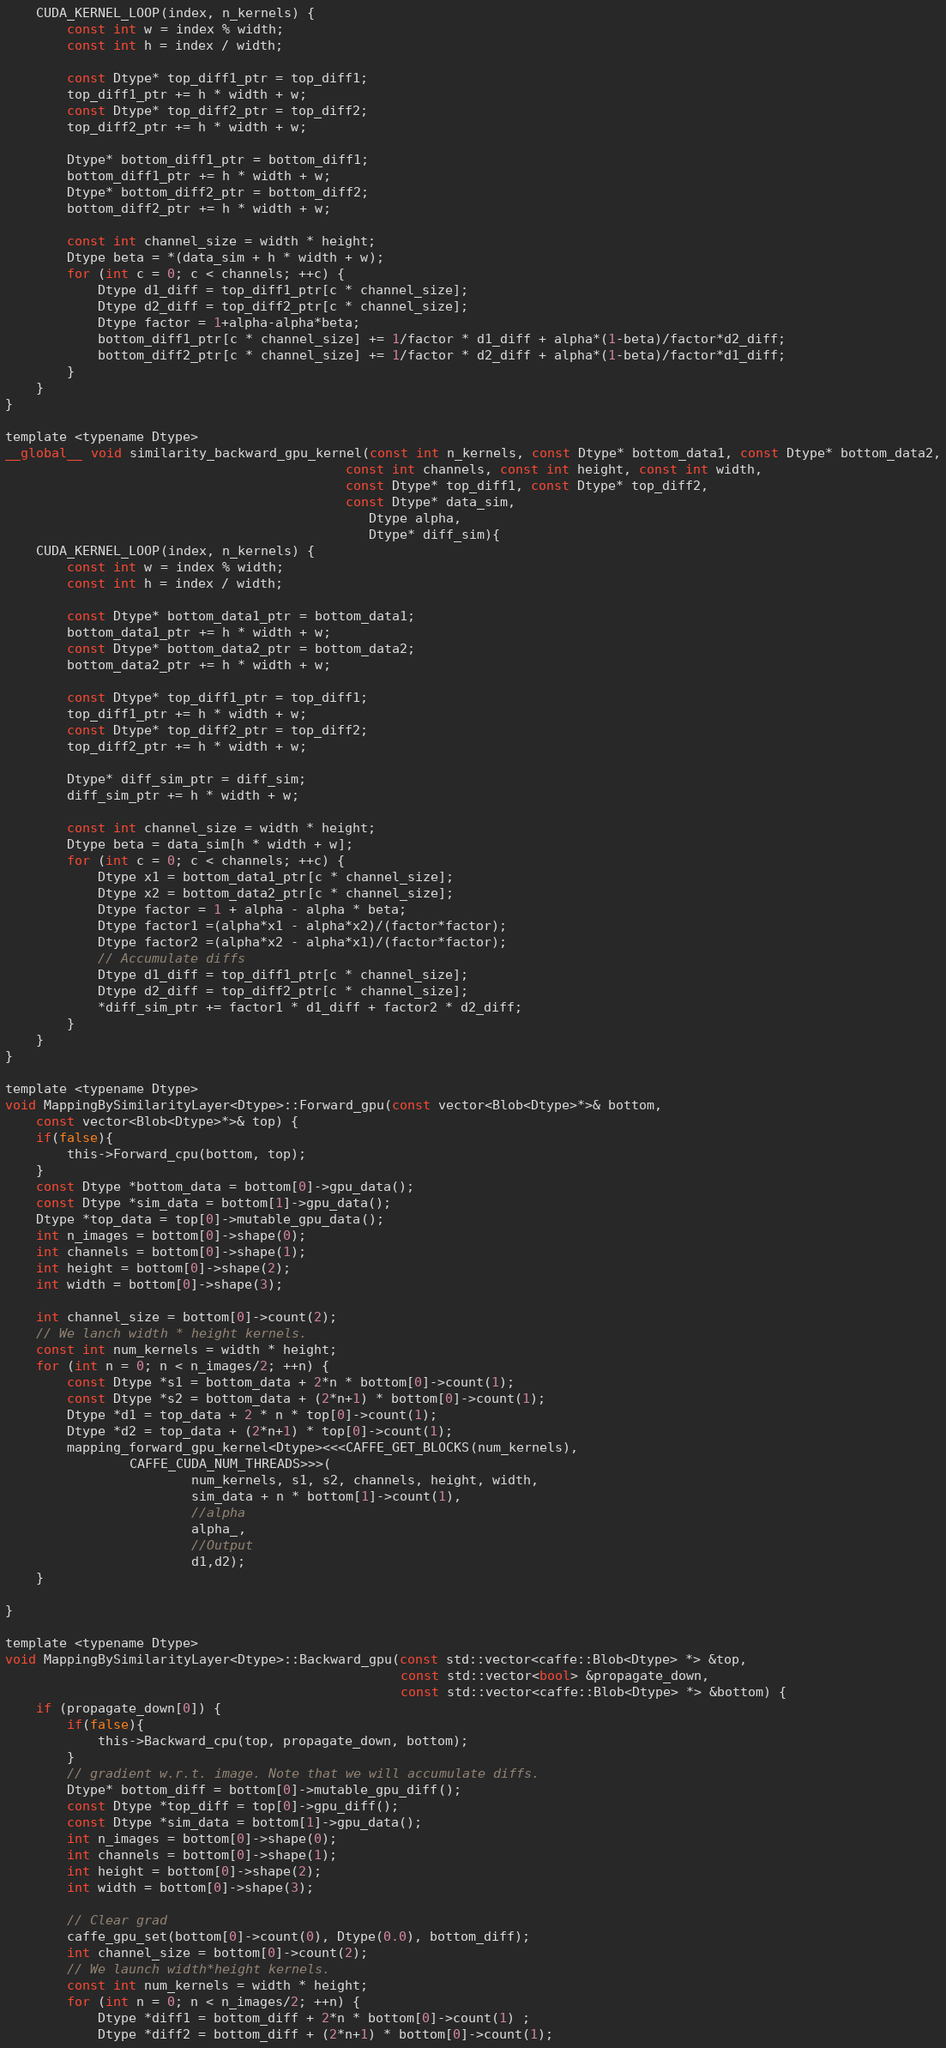Convert code to text. <code><loc_0><loc_0><loc_500><loc_500><_Cuda_>    CUDA_KERNEL_LOOP(index, n_kernels) {
        const int w = index % width;
        const int h = index / width;

        const Dtype* top_diff1_ptr = top_diff1;
        top_diff1_ptr += h * width + w;
        const Dtype* top_diff2_ptr = top_diff2;
        top_diff2_ptr += h * width + w;

        Dtype* bottom_diff1_ptr = bottom_diff1;
        bottom_diff1_ptr += h * width + w;
        Dtype* bottom_diff2_ptr = bottom_diff2;
        bottom_diff2_ptr += h * width + w;

        const int channel_size = width * height;
        Dtype beta = *(data_sim + h * width + w);
        for (int c = 0; c < channels; ++c) {
            Dtype d1_diff = top_diff1_ptr[c * channel_size];
            Dtype d2_diff = top_diff2_ptr[c * channel_size];
            Dtype factor = 1+alpha-alpha*beta;
            bottom_diff1_ptr[c * channel_size] += 1/factor * d1_diff + alpha*(1-beta)/factor*d2_diff;
            bottom_diff2_ptr[c * channel_size] += 1/factor * d2_diff + alpha*(1-beta)/factor*d1_diff;
        }
    }
}

template <typename Dtype>
__global__ void similarity_backward_gpu_kernel(const int n_kernels, const Dtype* bottom_data1, const Dtype* bottom_data2,
                                            const int channels, const int height, const int width,
                                            const Dtype* top_diff1, const Dtype* top_diff2,
                                            const Dtype* data_sim,
                                               Dtype alpha,
                                               Dtype* diff_sim){
    CUDA_KERNEL_LOOP(index, n_kernels) {
        const int w = index % width;
        const int h = index / width;

        const Dtype* bottom_data1_ptr = bottom_data1;
        bottom_data1_ptr += h * width + w;
        const Dtype* bottom_data2_ptr = bottom_data2;
        bottom_data2_ptr += h * width + w;

        const Dtype* top_diff1_ptr = top_diff1;
        top_diff1_ptr += h * width + w;
        const Dtype* top_diff2_ptr = top_diff2;
        top_diff2_ptr += h * width + w;

        Dtype* diff_sim_ptr = diff_sim;
        diff_sim_ptr += h * width + w;

        const int channel_size = width * height;
        Dtype beta = data_sim[h * width + w];
        for (int c = 0; c < channels; ++c) {
            Dtype x1 = bottom_data1_ptr[c * channel_size];
            Dtype x2 = bottom_data2_ptr[c * channel_size];
            Dtype factor = 1 + alpha - alpha * beta;
            Dtype factor1 =(alpha*x1 - alpha*x2)/(factor*factor);
            Dtype factor2 =(alpha*x2 - alpha*x1)/(factor*factor);
            // Accumulate diffs
            Dtype d1_diff = top_diff1_ptr[c * channel_size];
            Dtype d2_diff = top_diff2_ptr[c * channel_size];
            *diff_sim_ptr += factor1 * d1_diff + factor2 * d2_diff;
        }
    }
}

template <typename Dtype>
void MappingBySimilarityLayer<Dtype>::Forward_gpu(const vector<Blob<Dtype>*>& bottom,
    const vector<Blob<Dtype>*>& top) {
    if(false){
        this->Forward_cpu(bottom, top);
    }
    const Dtype *bottom_data = bottom[0]->gpu_data();
    const Dtype *sim_data = bottom[1]->gpu_data();
    Dtype *top_data = top[0]->mutable_gpu_data();
    int n_images = bottom[0]->shape(0);
    int channels = bottom[0]->shape(1);
    int height = bottom[0]->shape(2);
    int width = bottom[0]->shape(3);

    int channel_size = bottom[0]->count(2);
    // We lanch width * height kernels.
    const int num_kernels = width * height;
    for (int n = 0; n < n_images/2; ++n) {
        const Dtype *s1 = bottom_data + 2*n * bottom[0]->count(1);
        const Dtype *s2 = bottom_data + (2*n+1) * bottom[0]->count(1);
        Dtype *d1 = top_data + 2 * n * top[0]->count(1);
        Dtype *d2 = top_data + (2*n+1) * top[0]->count(1);
        mapping_forward_gpu_kernel<Dtype><<<CAFFE_GET_BLOCKS(num_kernels),
                CAFFE_CUDA_NUM_THREADS>>>(
                        num_kernels, s1, s2, channels, height, width,
                        sim_data + n * bottom[1]->count(1),
                        //alpha
                        alpha_,
                        //Output
                        d1,d2);
    }

}

template <typename Dtype>
void MappingBySimilarityLayer<Dtype>::Backward_gpu(const std::vector<caffe::Blob<Dtype> *> &top,
                                                   const std::vector<bool> &propagate_down,
                                                   const std::vector<caffe::Blob<Dtype> *> &bottom) {
    if (propagate_down[0]) {
        if(false){
            this->Backward_cpu(top, propagate_down, bottom);
        }
        // gradient w.r.t. image. Note that we will accumulate diffs.
        Dtype* bottom_diff = bottom[0]->mutable_gpu_diff();
        const Dtype *top_diff = top[0]->gpu_diff();
        const Dtype *sim_data = bottom[1]->gpu_data();
        int n_images = bottom[0]->shape(0);
        int channels = bottom[0]->shape(1);
        int height = bottom[0]->shape(2);
        int width = bottom[0]->shape(3);

        // Clear grad
        caffe_gpu_set(bottom[0]->count(0), Dtype(0.0), bottom_diff);
        int channel_size = bottom[0]->count(2);
        // We launch width*height kernels.
        const int num_kernels = width * height;
        for (int n = 0; n < n_images/2; ++n) {
            Dtype *diff1 = bottom_diff + 2*n * bottom[0]->count(1) ;
            Dtype *diff2 = bottom_diff + (2*n+1) * bottom[0]->count(1);</code> 